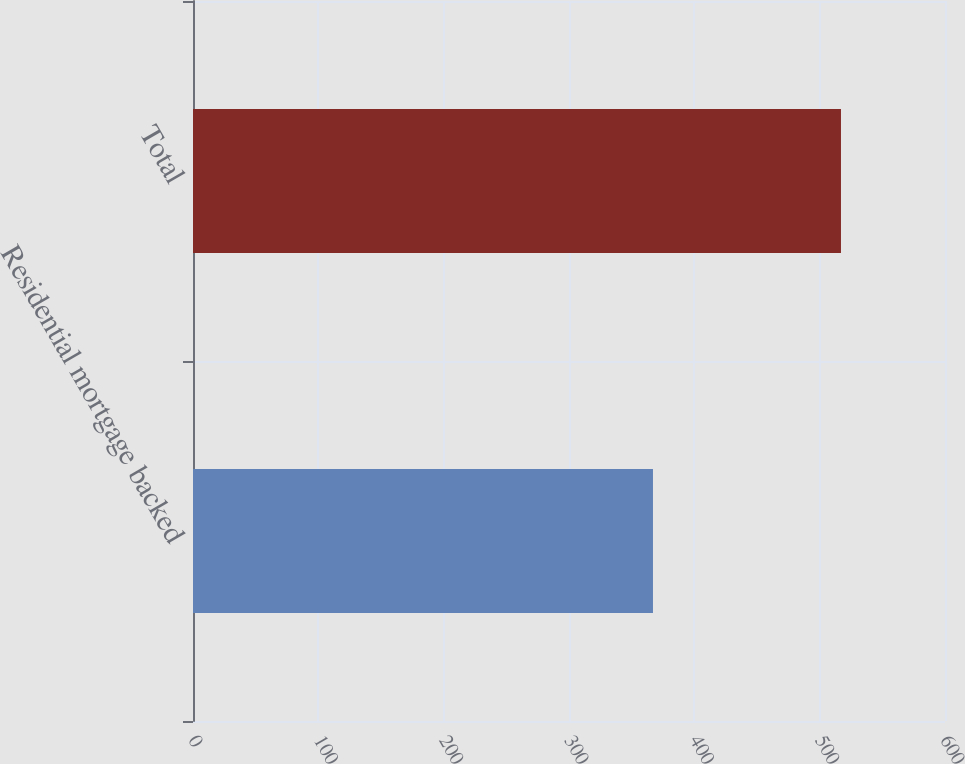Convert chart. <chart><loc_0><loc_0><loc_500><loc_500><bar_chart><fcel>Residential mortgage backed<fcel>Total<nl><fcel>367<fcel>517<nl></chart> 